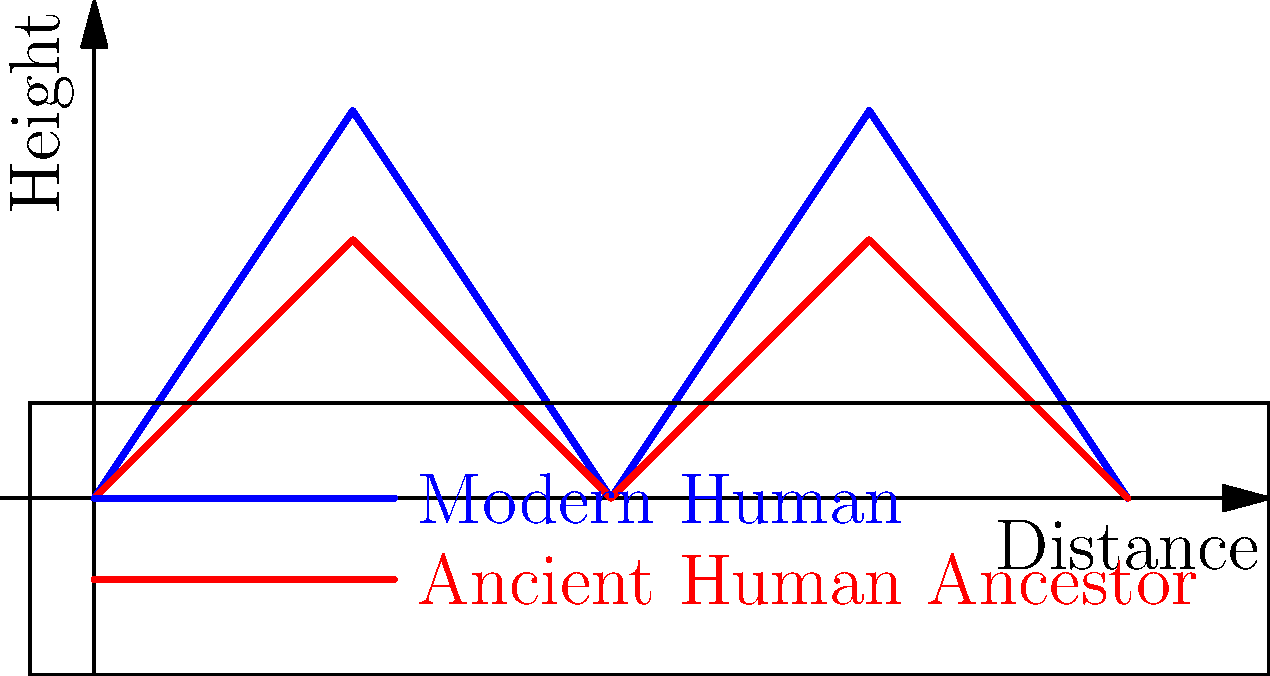Based on the skeletal reconstructions and gait patterns shown in the graph, what key difference can be observed between the walking patterns of modern humans and their ancient ancestors? To answer this question, we need to analyze the gait patterns represented in the graph:

1. The blue line represents the modern human gait, while the red line represents the ancient human ancestor gait.

2. Observe the vertical displacement (height) of each gait pattern:
   - The modern human gait (blue) shows greater vertical displacement.
   - The ancient human ancestor gait (red) shows less vertical displacement.

3. The greater vertical displacement in the modern human gait indicates:
   - A more pronounced up-and-down movement during walking.
   - Likely a result of a more extended leg stance and larger stride length.

4. The lesser vertical displacement in the ancient human ancestor gait suggests:
   - A flatter, more shuffling gait.
   - Possibly due to a more bent-knee, bent-hip posture.

5. This difference in gait patterns reflects evolutionary changes in human bipedalism:
   - Modern humans have developed a more energy-efficient walking style.
   - Ancient ancestors had a gait that was transitional between quadrupedal and fully bipedal locomotion.

The key difference, therefore, is the greater vertical displacement in the modern human gait, indicating a more pronounced up-and-down movement during walking compared to ancient human ancestors.
Answer: Greater vertical displacement in modern human gait 